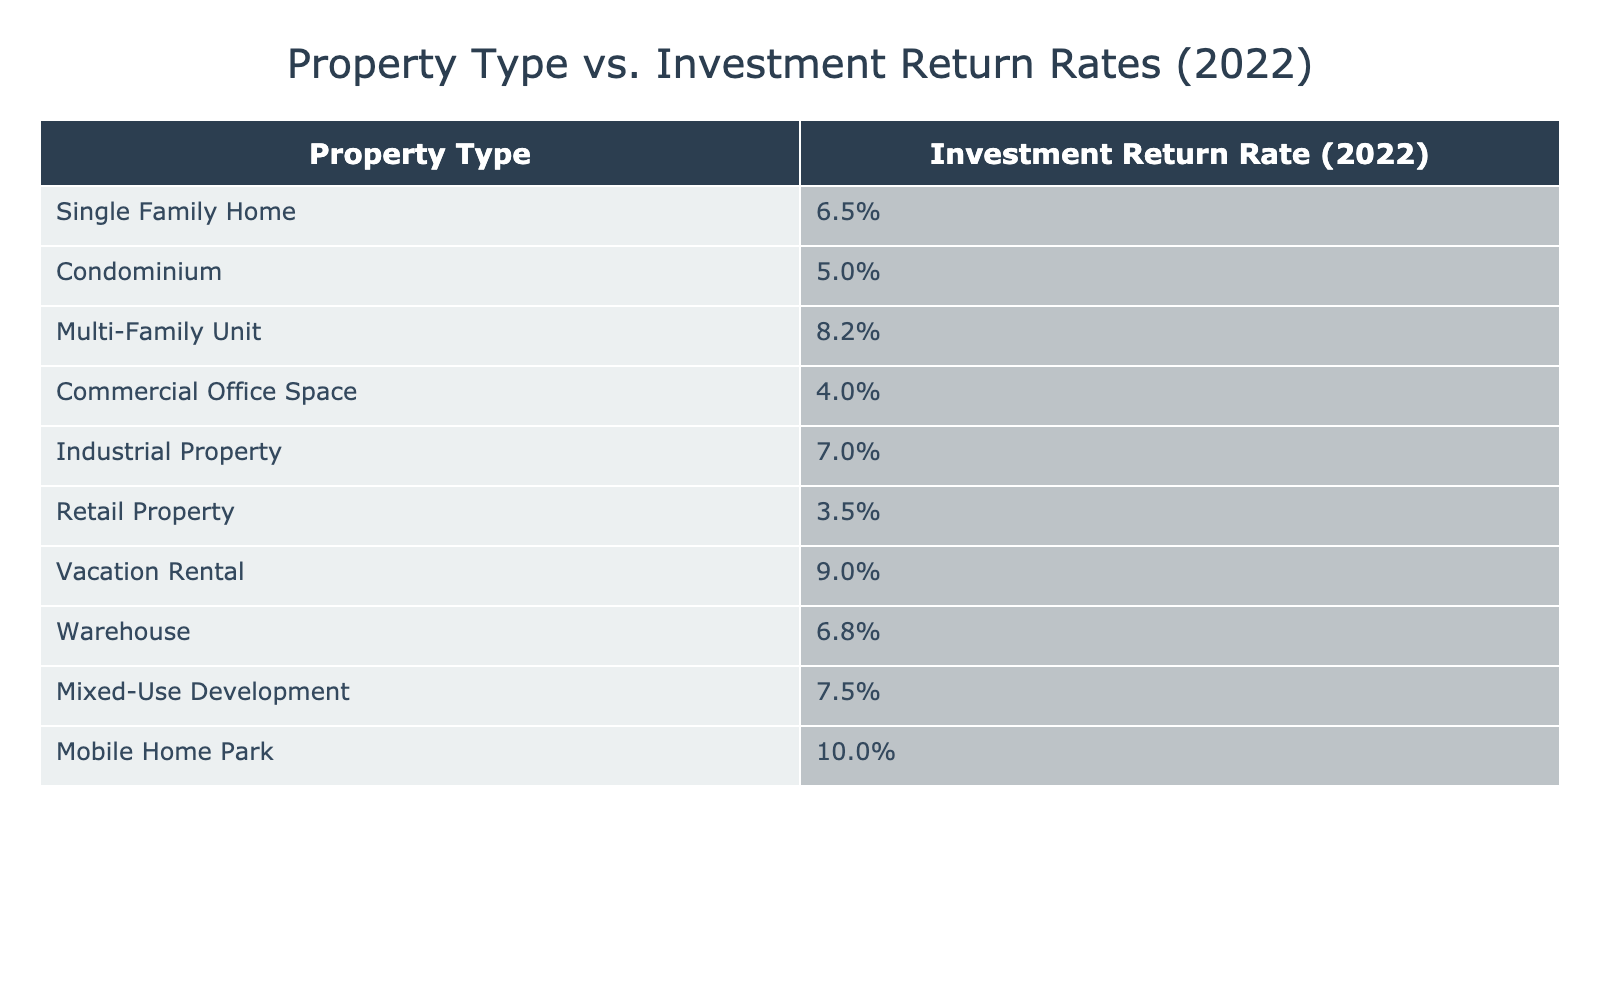What is the investment return rate for Vacation Rentals in 2022? According to the table, the investment return rate for Vacation Rentals is displayed, and it states 9.0%.
Answer: 9.0% Which property type has the highest investment return rate in 2022? By looking at the investment return rates listed in the table, the Mobile Home Park has the highest rate of 10.0%.
Answer: Mobile Home Park What is the average investment return rate of Single Family Homes, Condominiums, and Multi-Family Units in 2022? The investment return rates for these properties are 6.5%, 5.0%, and 8.2% respectively. First, sum these values: 6.5 + 5.0 + 8.2 = 19.7. Next, divide by the number of properties: 19.7 / 3 = 6.57. Therefore, the average investment return rate is approximately 6.57%.
Answer: 6.57% Is the investment return rate for Industrial Property higher than that for Commercial Office Space? The investment return rate for Industrial Property is 7.0% and for Commercial Office Space, it is 4.0%. Since 7.0% is greater than 4.0%, the answer is yes.
Answer: Yes What is the difference in investment return rates between Mobile Home Parks and Retail Properties in 2022? The investment return rate of Mobile Home Parks is 10.0% while that of Retail Properties is 3.5%. To find the difference, subtract the Retail Property rate from the Mobile Home Park rate: 10.0% - 3.5% = 6.5%.
Answer: 6.5% 